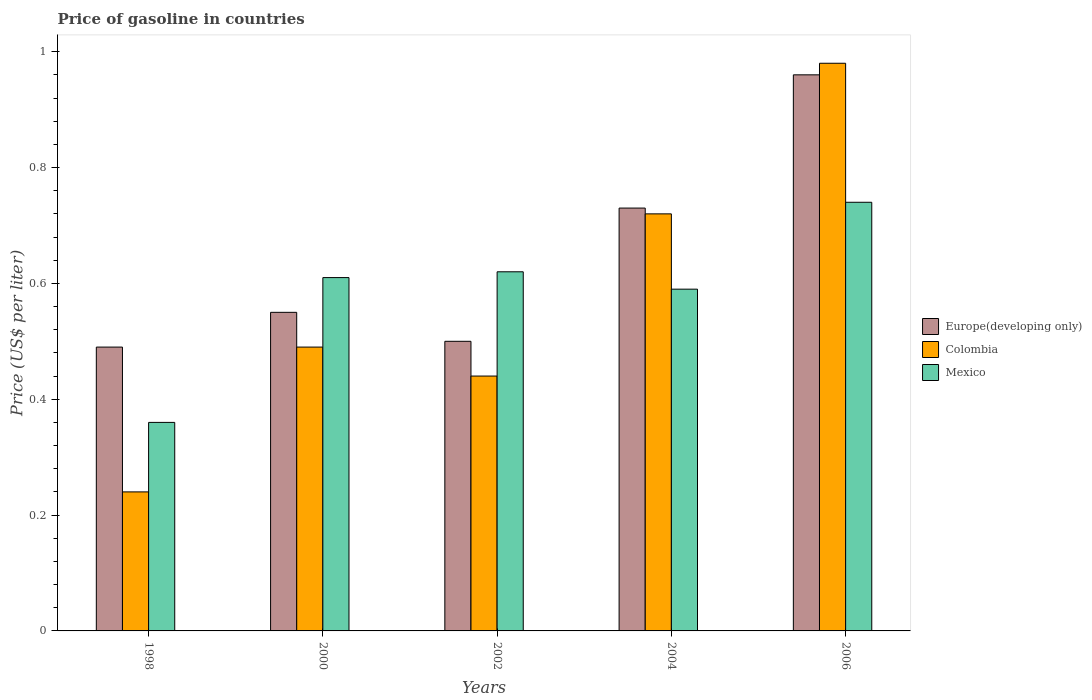How many different coloured bars are there?
Ensure brevity in your answer.  3. How many groups of bars are there?
Provide a succinct answer. 5. Are the number of bars on each tick of the X-axis equal?
Provide a short and direct response. Yes. What is the price of gasoline in Mexico in 1998?
Offer a terse response. 0.36. Across all years, what is the maximum price of gasoline in Europe(developing only)?
Offer a very short reply. 0.96. Across all years, what is the minimum price of gasoline in Europe(developing only)?
Ensure brevity in your answer.  0.49. In which year was the price of gasoline in Colombia maximum?
Ensure brevity in your answer.  2006. What is the total price of gasoline in Colombia in the graph?
Make the answer very short. 2.87. What is the difference between the price of gasoline in Colombia in 2000 and that in 2002?
Your answer should be compact. 0.05. What is the difference between the price of gasoline in Mexico in 1998 and the price of gasoline in Colombia in 2006?
Provide a short and direct response. -0.62. What is the average price of gasoline in Colombia per year?
Give a very brief answer. 0.57. In the year 2006, what is the difference between the price of gasoline in Mexico and price of gasoline in Colombia?
Offer a very short reply. -0.24. In how many years, is the price of gasoline in Mexico greater than 0.6000000000000001 US$?
Your answer should be compact. 3. Is the price of gasoline in Europe(developing only) in 2002 less than that in 2004?
Give a very brief answer. Yes. What is the difference between the highest and the second highest price of gasoline in Colombia?
Your answer should be very brief. 0.26. What is the difference between the highest and the lowest price of gasoline in Europe(developing only)?
Your answer should be very brief. 0.47. In how many years, is the price of gasoline in Colombia greater than the average price of gasoline in Colombia taken over all years?
Your answer should be very brief. 2. What does the 2nd bar from the left in 2004 represents?
Your answer should be very brief. Colombia. What does the 1st bar from the right in 2006 represents?
Keep it short and to the point. Mexico. Is it the case that in every year, the sum of the price of gasoline in Colombia and price of gasoline in Europe(developing only) is greater than the price of gasoline in Mexico?
Offer a terse response. Yes. Are all the bars in the graph horizontal?
Offer a very short reply. No. How many years are there in the graph?
Give a very brief answer. 5. What is the difference between two consecutive major ticks on the Y-axis?
Give a very brief answer. 0.2. Does the graph contain any zero values?
Your response must be concise. No. What is the title of the graph?
Make the answer very short. Price of gasoline in countries. Does "Kazakhstan" appear as one of the legend labels in the graph?
Ensure brevity in your answer.  No. What is the label or title of the Y-axis?
Provide a short and direct response. Price (US$ per liter). What is the Price (US$ per liter) in Europe(developing only) in 1998?
Offer a very short reply. 0.49. What is the Price (US$ per liter) in Colombia in 1998?
Offer a very short reply. 0.24. What is the Price (US$ per liter) in Mexico in 1998?
Make the answer very short. 0.36. What is the Price (US$ per liter) of Europe(developing only) in 2000?
Your response must be concise. 0.55. What is the Price (US$ per liter) in Colombia in 2000?
Your answer should be compact. 0.49. What is the Price (US$ per liter) of Mexico in 2000?
Your answer should be compact. 0.61. What is the Price (US$ per liter) of Colombia in 2002?
Make the answer very short. 0.44. What is the Price (US$ per liter) in Mexico in 2002?
Provide a short and direct response. 0.62. What is the Price (US$ per liter) of Europe(developing only) in 2004?
Your answer should be very brief. 0.73. What is the Price (US$ per liter) of Colombia in 2004?
Keep it short and to the point. 0.72. What is the Price (US$ per liter) of Mexico in 2004?
Your response must be concise. 0.59. What is the Price (US$ per liter) in Colombia in 2006?
Ensure brevity in your answer.  0.98. What is the Price (US$ per liter) in Mexico in 2006?
Offer a very short reply. 0.74. Across all years, what is the maximum Price (US$ per liter) of Europe(developing only)?
Your answer should be very brief. 0.96. Across all years, what is the maximum Price (US$ per liter) of Mexico?
Your answer should be compact. 0.74. Across all years, what is the minimum Price (US$ per liter) of Europe(developing only)?
Offer a very short reply. 0.49. Across all years, what is the minimum Price (US$ per liter) of Colombia?
Keep it short and to the point. 0.24. Across all years, what is the minimum Price (US$ per liter) of Mexico?
Keep it short and to the point. 0.36. What is the total Price (US$ per liter) of Europe(developing only) in the graph?
Make the answer very short. 3.23. What is the total Price (US$ per liter) of Colombia in the graph?
Ensure brevity in your answer.  2.87. What is the total Price (US$ per liter) of Mexico in the graph?
Provide a short and direct response. 2.92. What is the difference between the Price (US$ per liter) of Europe(developing only) in 1998 and that in 2000?
Keep it short and to the point. -0.06. What is the difference between the Price (US$ per liter) of Europe(developing only) in 1998 and that in 2002?
Give a very brief answer. -0.01. What is the difference between the Price (US$ per liter) in Mexico in 1998 and that in 2002?
Offer a very short reply. -0.26. What is the difference between the Price (US$ per liter) of Europe(developing only) in 1998 and that in 2004?
Your answer should be very brief. -0.24. What is the difference between the Price (US$ per liter) in Colombia in 1998 and that in 2004?
Keep it short and to the point. -0.48. What is the difference between the Price (US$ per liter) in Mexico in 1998 and that in 2004?
Keep it short and to the point. -0.23. What is the difference between the Price (US$ per liter) of Europe(developing only) in 1998 and that in 2006?
Offer a terse response. -0.47. What is the difference between the Price (US$ per liter) of Colombia in 1998 and that in 2006?
Keep it short and to the point. -0.74. What is the difference between the Price (US$ per liter) of Mexico in 1998 and that in 2006?
Give a very brief answer. -0.38. What is the difference between the Price (US$ per liter) of Colombia in 2000 and that in 2002?
Your response must be concise. 0.05. What is the difference between the Price (US$ per liter) of Mexico in 2000 and that in 2002?
Your answer should be very brief. -0.01. What is the difference between the Price (US$ per liter) of Europe(developing only) in 2000 and that in 2004?
Ensure brevity in your answer.  -0.18. What is the difference between the Price (US$ per liter) of Colombia in 2000 and that in 2004?
Make the answer very short. -0.23. What is the difference between the Price (US$ per liter) of Mexico in 2000 and that in 2004?
Your response must be concise. 0.02. What is the difference between the Price (US$ per liter) in Europe(developing only) in 2000 and that in 2006?
Your answer should be compact. -0.41. What is the difference between the Price (US$ per liter) in Colombia in 2000 and that in 2006?
Ensure brevity in your answer.  -0.49. What is the difference between the Price (US$ per liter) of Mexico in 2000 and that in 2006?
Provide a short and direct response. -0.13. What is the difference between the Price (US$ per liter) in Europe(developing only) in 2002 and that in 2004?
Your answer should be very brief. -0.23. What is the difference between the Price (US$ per liter) in Colombia in 2002 and that in 2004?
Your response must be concise. -0.28. What is the difference between the Price (US$ per liter) of Europe(developing only) in 2002 and that in 2006?
Your answer should be compact. -0.46. What is the difference between the Price (US$ per liter) of Colombia in 2002 and that in 2006?
Give a very brief answer. -0.54. What is the difference between the Price (US$ per liter) of Mexico in 2002 and that in 2006?
Provide a short and direct response. -0.12. What is the difference between the Price (US$ per liter) of Europe(developing only) in 2004 and that in 2006?
Provide a short and direct response. -0.23. What is the difference between the Price (US$ per liter) in Colombia in 2004 and that in 2006?
Make the answer very short. -0.26. What is the difference between the Price (US$ per liter) in Mexico in 2004 and that in 2006?
Offer a terse response. -0.15. What is the difference between the Price (US$ per liter) in Europe(developing only) in 1998 and the Price (US$ per liter) in Mexico in 2000?
Make the answer very short. -0.12. What is the difference between the Price (US$ per liter) in Colombia in 1998 and the Price (US$ per liter) in Mexico in 2000?
Ensure brevity in your answer.  -0.37. What is the difference between the Price (US$ per liter) of Europe(developing only) in 1998 and the Price (US$ per liter) of Colombia in 2002?
Ensure brevity in your answer.  0.05. What is the difference between the Price (US$ per liter) of Europe(developing only) in 1998 and the Price (US$ per liter) of Mexico in 2002?
Your answer should be very brief. -0.13. What is the difference between the Price (US$ per liter) in Colombia in 1998 and the Price (US$ per liter) in Mexico in 2002?
Make the answer very short. -0.38. What is the difference between the Price (US$ per liter) in Europe(developing only) in 1998 and the Price (US$ per liter) in Colombia in 2004?
Offer a very short reply. -0.23. What is the difference between the Price (US$ per liter) in Colombia in 1998 and the Price (US$ per liter) in Mexico in 2004?
Provide a short and direct response. -0.35. What is the difference between the Price (US$ per liter) of Europe(developing only) in 1998 and the Price (US$ per liter) of Colombia in 2006?
Provide a short and direct response. -0.49. What is the difference between the Price (US$ per liter) of Europe(developing only) in 1998 and the Price (US$ per liter) of Mexico in 2006?
Provide a succinct answer. -0.25. What is the difference between the Price (US$ per liter) of Europe(developing only) in 2000 and the Price (US$ per liter) of Colombia in 2002?
Provide a short and direct response. 0.11. What is the difference between the Price (US$ per liter) of Europe(developing only) in 2000 and the Price (US$ per liter) of Mexico in 2002?
Ensure brevity in your answer.  -0.07. What is the difference between the Price (US$ per liter) in Colombia in 2000 and the Price (US$ per liter) in Mexico in 2002?
Give a very brief answer. -0.13. What is the difference between the Price (US$ per liter) of Europe(developing only) in 2000 and the Price (US$ per liter) of Colombia in 2004?
Offer a very short reply. -0.17. What is the difference between the Price (US$ per liter) in Europe(developing only) in 2000 and the Price (US$ per liter) in Mexico in 2004?
Offer a terse response. -0.04. What is the difference between the Price (US$ per liter) of Europe(developing only) in 2000 and the Price (US$ per liter) of Colombia in 2006?
Give a very brief answer. -0.43. What is the difference between the Price (US$ per liter) in Europe(developing only) in 2000 and the Price (US$ per liter) in Mexico in 2006?
Give a very brief answer. -0.19. What is the difference between the Price (US$ per liter) in Europe(developing only) in 2002 and the Price (US$ per liter) in Colombia in 2004?
Your answer should be very brief. -0.22. What is the difference between the Price (US$ per liter) of Europe(developing only) in 2002 and the Price (US$ per liter) of Mexico in 2004?
Your answer should be compact. -0.09. What is the difference between the Price (US$ per liter) of Europe(developing only) in 2002 and the Price (US$ per liter) of Colombia in 2006?
Provide a succinct answer. -0.48. What is the difference between the Price (US$ per liter) in Europe(developing only) in 2002 and the Price (US$ per liter) in Mexico in 2006?
Keep it short and to the point. -0.24. What is the difference between the Price (US$ per liter) in Colombia in 2002 and the Price (US$ per liter) in Mexico in 2006?
Your answer should be very brief. -0.3. What is the difference between the Price (US$ per liter) in Europe(developing only) in 2004 and the Price (US$ per liter) in Colombia in 2006?
Give a very brief answer. -0.25. What is the difference between the Price (US$ per liter) of Europe(developing only) in 2004 and the Price (US$ per liter) of Mexico in 2006?
Give a very brief answer. -0.01. What is the difference between the Price (US$ per liter) in Colombia in 2004 and the Price (US$ per liter) in Mexico in 2006?
Give a very brief answer. -0.02. What is the average Price (US$ per liter) of Europe(developing only) per year?
Offer a terse response. 0.65. What is the average Price (US$ per liter) in Colombia per year?
Your answer should be compact. 0.57. What is the average Price (US$ per liter) in Mexico per year?
Ensure brevity in your answer.  0.58. In the year 1998, what is the difference between the Price (US$ per liter) of Europe(developing only) and Price (US$ per liter) of Mexico?
Make the answer very short. 0.13. In the year 1998, what is the difference between the Price (US$ per liter) of Colombia and Price (US$ per liter) of Mexico?
Provide a succinct answer. -0.12. In the year 2000, what is the difference between the Price (US$ per liter) in Europe(developing only) and Price (US$ per liter) in Mexico?
Your response must be concise. -0.06. In the year 2000, what is the difference between the Price (US$ per liter) of Colombia and Price (US$ per liter) of Mexico?
Provide a short and direct response. -0.12. In the year 2002, what is the difference between the Price (US$ per liter) in Europe(developing only) and Price (US$ per liter) in Mexico?
Provide a short and direct response. -0.12. In the year 2002, what is the difference between the Price (US$ per liter) of Colombia and Price (US$ per liter) of Mexico?
Provide a short and direct response. -0.18. In the year 2004, what is the difference between the Price (US$ per liter) of Europe(developing only) and Price (US$ per liter) of Colombia?
Your answer should be compact. 0.01. In the year 2004, what is the difference between the Price (US$ per liter) of Europe(developing only) and Price (US$ per liter) of Mexico?
Offer a terse response. 0.14. In the year 2004, what is the difference between the Price (US$ per liter) in Colombia and Price (US$ per liter) in Mexico?
Keep it short and to the point. 0.13. In the year 2006, what is the difference between the Price (US$ per liter) in Europe(developing only) and Price (US$ per liter) in Colombia?
Your answer should be compact. -0.02. In the year 2006, what is the difference between the Price (US$ per liter) in Europe(developing only) and Price (US$ per liter) in Mexico?
Make the answer very short. 0.22. In the year 2006, what is the difference between the Price (US$ per liter) of Colombia and Price (US$ per liter) of Mexico?
Provide a succinct answer. 0.24. What is the ratio of the Price (US$ per liter) of Europe(developing only) in 1998 to that in 2000?
Your response must be concise. 0.89. What is the ratio of the Price (US$ per liter) of Colombia in 1998 to that in 2000?
Make the answer very short. 0.49. What is the ratio of the Price (US$ per liter) of Mexico in 1998 to that in 2000?
Keep it short and to the point. 0.59. What is the ratio of the Price (US$ per liter) of Colombia in 1998 to that in 2002?
Make the answer very short. 0.55. What is the ratio of the Price (US$ per liter) in Mexico in 1998 to that in 2002?
Keep it short and to the point. 0.58. What is the ratio of the Price (US$ per liter) of Europe(developing only) in 1998 to that in 2004?
Your answer should be very brief. 0.67. What is the ratio of the Price (US$ per liter) of Colombia in 1998 to that in 2004?
Provide a short and direct response. 0.33. What is the ratio of the Price (US$ per liter) in Mexico in 1998 to that in 2004?
Your answer should be compact. 0.61. What is the ratio of the Price (US$ per liter) of Europe(developing only) in 1998 to that in 2006?
Provide a succinct answer. 0.51. What is the ratio of the Price (US$ per liter) of Colombia in 1998 to that in 2006?
Your answer should be compact. 0.24. What is the ratio of the Price (US$ per liter) in Mexico in 1998 to that in 2006?
Offer a very short reply. 0.49. What is the ratio of the Price (US$ per liter) in Europe(developing only) in 2000 to that in 2002?
Give a very brief answer. 1.1. What is the ratio of the Price (US$ per liter) in Colombia in 2000 to that in 2002?
Ensure brevity in your answer.  1.11. What is the ratio of the Price (US$ per liter) of Mexico in 2000 to that in 2002?
Provide a short and direct response. 0.98. What is the ratio of the Price (US$ per liter) of Europe(developing only) in 2000 to that in 2004?
Offer a very short reply. 0.75. What is the ratio of the Price (US$ per liter) in Colombia in 2000 to that in 2004?
Your response must be concise. 0.68. What is the ratio of the Price (US$ per liter) in Mexico in 2000 to that in 2004?
Offer a very short reply. 1.03. What is the ratio of the Price (US$ per liter) in Europe(developing only) in 2000 to that in 2006?
Provide a short and direct response. 0.57. What is the ratio of the Price (US$ per liter) of Mexico in 2000 to that in 2006?
Keep it short and to the point. 0.82. What is the ratio of the Price (US$ per liter) in Europe(developing only) in 2002 to that in 2004?
Make the answer very short. 0.68. What is the ratio of the Price (US$ per liter) of Colombia in 2002 to that in 2004?
Make the answer very short. 0.61. What is the ratio of the Price (US$ per liter) of Mexico in 2002 to that in 2004?
Give a very brief answer. 1.05. What is the ratio of the Price (US$ per liter) in Europe(developing only) in 2002 to that in 2006?
Ensure brevity in your answer.  0.52. What is the ratio of the Price (US$ per liter) in Colombia in 2002 to that in 2006?
Provide a short and direct response. 0.45. What is the ratio of the Price (US$ per liter) of Mexico in 2002 to that in 2006?
Your answer should be very brief. 0.84. What is the ratio of the Price (US$ per liter) of Europe(developing only) in 2004 to that in 2006?
Make the answer very short. 0.76. What is the ratio of the Price (US$ per liter) of Colombia in 2004 to that in 2006?
Your answer should be compact. 0.73. What is the ratio of the Price (US$ per liter) in Mexico in 2004 to that in 2006?
Ensure brevity in your answer.  0.8. What is the difference between the highest and the second highest Price (US$ per liter) of Europe(developing only)?
Your answer should be very brief. 0.23. What is the difference between the highest and the second highest Price (US$ per liter) of Colombia?
Provide a succinct answer. 0.26. What is the difference between the highest and the second highest Price (US$ per liter) in Mexico?
Ensure brevity in your answer.  0.12. What is the difference between the highest and the lowest Price (US$ per liter) of Europe(developing only)?
Your answer should be compact. 0.47. What is the difference between the highest and the lowest Price (US$ per liter) of Colombia?
Keep it short and to the point. 0.74. What is the difference between the highest and the lowest Price (US$ per liter) in Mexico?
Provide a short and direct response. 0.38. 